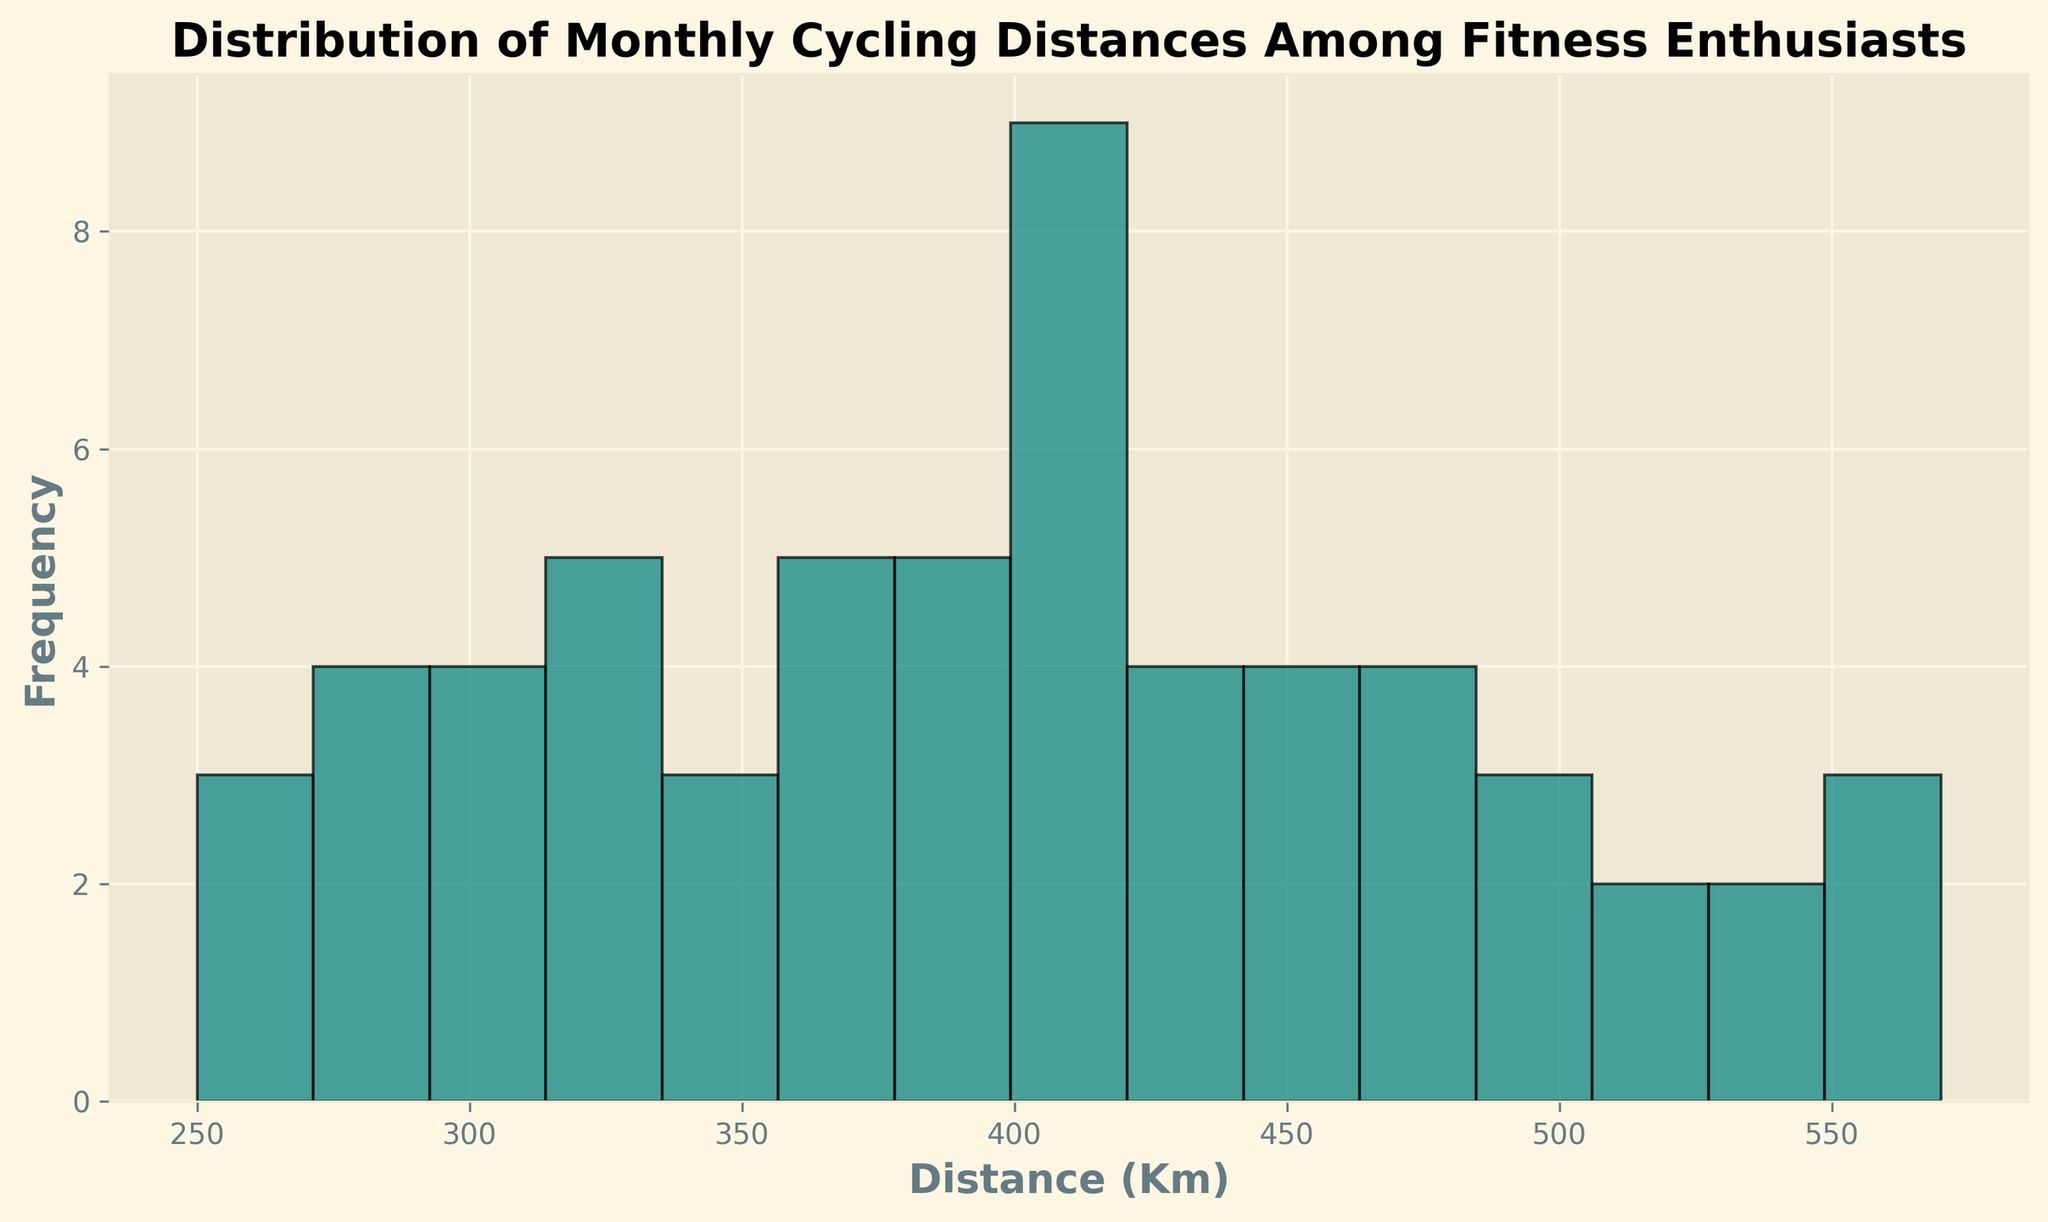What is the most frequent range of monthly cycling distances among enthusiasts? By looking at the histogram, find the tallest bar and identify the range it represents on the x-axis. This range has the highest frequency.
Answer: 300-350 Km How many enthusiasts cycled between 350 and 400 Km in a month? Look at the histogram bar that represents the 350-400 Km range and read off its height. This height gives the number of enthusiasts in that range.
Answer: 7 Which range has fewer cyclists, 250-300 Km or 450-500 Km? Compare the heights of the histogram bars for the ranges 250-300 Km and 450-500 Km. The shorter bar indicates fewer cyclists.
Answer: 450-500 Km What is the total number of cyclists who cycled between 200 Km and 450 Km? Sum up the heights of all histogram bars that fall within 200-450 Km. This includes bars representing the ranges 200-250 Km, 250-300 Km, 300-350 Km, 350-400 Km, and 400-450 Km.
Answer: 26 Is the distribution of monthly cycling distances skewed left, right, or symmetric? Evaluate the shape of the histogram. If most data is concentrated on the left and tails off to the right, it's right-skewed. If the opposite, it's left-skewed. If it's evenly spread out, it's symmetric.
Answer: Right-skewed What is the approximate median range of monthly cycling distances? Locate the range where the cumulative frequency reaches half of the total number of cyclists. The middle of the histogram, where it divides evenly, indicates the median range.
Answer: 350-400 Km In which range do the frequencies start to noticeably drop off? Identify the range on the histogram where the bar heights significantly decrease compared to previous ranges. This suggests a drop in frequencies.
Answer: 450-500 Km Which range has the second-highest number of cyclists? After identifying the bar with the highest frequency, find the next tallest bar and note down the range it represents.
Answer: 400-450 Km How does the frequency of the range 500-550 Km compare to the range 550-600 Km? Compare the heights of the bars representing 500-550 Km and 550-600 Km. Determine if one is taller, shorter, or if they are equal.
Answer: Higher in 500-550 Km 